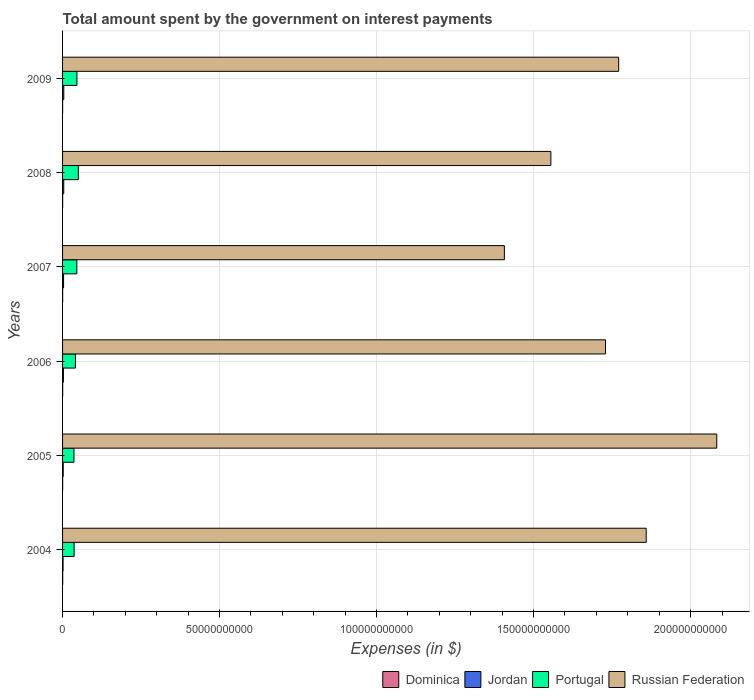How many groups of bars are there?
Offer a very short reply. 6. Are the number of bars per tick equal to the number of legend labels?
Provide a short and direct response. Yes. How many bars are there on the 6th tick from the top?
Provide a short and direct response. 4. How many bars are there on the 1st tick from the bottom?
Your answer should be compact. 4. What is the label of the 2nd group of bars from the top?
Give a very brief answer. 2008. What is the amount spent on interest payments by the government in Russian Federation in 2004?
Ensure brevity in your answer.  1.86e+11. Across all years, what is the maximum amount spent on interest payments by the government in Dominica?
Make the answer very short. 4.16e+07. Across all years, what is the minimum amount spent on interest payments by the government in Dominica?
Make the answer very short. 1.41e+07. In which year was the amount spent on interest payments by the government in Jordan minimum?
Your response must be concise. 2004. What is the total amount spent on interest payments by the government in Portugal in the graph?
Offer a very short reply. 2.55e+1. What is the difference between the amount spent on interest payments by the government in Russian Federation in 2005 and that in 2008?
Ensure brevity in your answer.  5.28e+1. What is the difference between the amount spent on interest payments by the government in Portugal in 2006 and the amount spent on interest payments by the government in Russian Federation in 2007?
Offer a terse response. -1.37e+11. What is the average amount spent on interest payments by the government in Dominica per year?
Your answer should be very brief. 2.82e+07. In the year 2007, what is the difference between the amount spent on interest payments by the government in Jordan and amount spent on interest payments by the government in Portugal?
Your answer should be compact. -4.22e+09. What is the ratio of the amount spent on interest payments by the government in Jordan in 2005 to that in 2007?
Ensure brevity in your answer.  0.65. Is the amount spent on interest payments by the government in Dominica in 2007 less than that in 2009?
Provide a short and direct response. No. What is the difference between the highest and the second highest amount spent on interest payments by the government in Jordan?
Your answer should be very brief. 1.44e+07. What is the difference between the highest and the lowest amount spent on interest payments by the government in Russian Federation?
Give a very brief answer. 6.76e+1. In how many years, is the amount spent on interest payments by the government in Portugal greater than the average amount spent on interest payments by the government in Portugal taken over all years?
Ensure brevity in your answer.  3. What does the 3rd bar from the top in 2008 represents?
Offer a very short reply. Jordan. What does the 3rd bar from the bottom in 2008 represents?
Keep it short and to the point. Portugal. How many bars are there?
Make the answer very short. 24. Are all the bars in the graph horizontal?
Offer a very short reply. Yes. What is the difference between two consecutive major ticks on the X-axis?
Make the answer very short. 5.00e+1. Are the values on the major ticks of X-axis written in scientific E-notation?
Ensure brevity in your answer.  No. Does the graph contain grids?
Your answer should be compact. Yes. How are the legend labels stacked?
Provide a succinct answer. Horizontal. What is the title of the graph?
Ensure brevity in your answer.  Total amount spent by the government on interest payments. Does "Slovak Republic" appear as one of the legend labels in the graph?
Your response must be concise. No. What is the label or title of the X-axis?
Keep it short and to the point. Expenses (in $). What is the Expenses (in $) in Dominica in 2004?
Give a very brief answer. 4.16e+07. What is the Expenses (in $) in Jordan in 2004?
Offer a very short reply. 1.61e+08. What is the Expenses (in $) of Portugal in 2004?
Your response must be concise. 3.68e+09. What is the Expenses (in $) of Russian Federation in 2004?
Offer a terse response. 1.86e+11. What is the Expenses (in $) in Dominica in 2005?
Your answer should be compact. 2.59e+07. What is the Expenses (in $) of Jordan in 2005?
Offer a terse response. 2.07e+08. What is the Expenses (in $) of Portugal in 2005?
Keep it short and to the point. 3.63e+09. What is the Expenses (in $) of Russian Federation in 2005?
Offer a terse response. 2.08e+11. What is the Expenses (in $) of Dominica in 2006?
Offer a terse response. 3.46e+07. What is the Expenses (in $) in Jordan in 2006?
Make the answer very short. 2.66e+08. What is the Expenses (in $) of Portugal in 2006?
Your answer should be very brief. 4.10e+09. What is the Expenses (in $) in Russian Federation in 2006?
Offer a very short reply. 1.73e+11. What is the Expenses (in $) of Dominica in 2007?
Give a very brief answer. 2.82e+07. What is the Expenses (in $) in Jordan in 2007?
Offer a very short reply. 3.21e+08. What is the Expenses (in $) of Portugal in 2007?
Provide a succinct answer. 4.54e+09. What is the Expenses (in $) in Russian Federation in 2007?
Your response must be concise. 1.41e+11. What is the Expenses (in $) in Dominica in 2008?
Provide a short and direct response. 2.45e+07. What is the Expenses (in $) in Jordan in 2008?
Make the answer very short. 3.78e+08. What is the Expenses (in $) of Portugal in 2008?
Give a very brief answer. 5.02e+09. What is the Expenses (in $) in Russian Federation in 2008?
Your answer should be very brief. 1.56e+11. What is the Expenses (in $) in Dominica in 2009?
Ensure brevity in your answer.  1.41e+07. What is the Expenses (in $) in Jordan in 2009?
Provide a short and direct response. 3.92e+08. What is the Expenses (in $) in Portugal in 2009?
Ensure brevity in your answer.  4.58e+09. What is the Expenses (in $) of Russian Federation in 2009?
Keep it short and to the point. 1.77e+11. Across all years, what is the maximum Expenses (in $) of Dominica?
Keep it short and to the point. 4.16e+07. Across all years, what is the maximum Expenses (in $) in Jordan?
Your response must be concise. 3.92e+08. Across all years, what is the maximum Expenses (in $) in Portugal?
Your answer should be compact. 5.02e+09. Across all years, what is the maximum Expenses (in $) in Russian Federation?
Give a very brief answer. 2.08e+11. Across all years, what is the minimum Expenses (in $) in Dominica?
Offer a terse response. 1.41e+07. Across all years, what is the minimum Expenses (in $) in Jordan?
Your answer should be compact. 1.61e+08. Across all years, what is the minimum Expenses (in $) of Portugal?
Give a very brief answer. 3.63e+09. Across all years, what is the minimum Expenses (in $) in Russian Federation?
Provide a short and direct response. 1.41e+11. What is the total Expenses (in $) of Dominica in the graph?
Ensure brevity in your answer.  1.69e+08. What is the total Expenses (in $) of Jordan in the graph?
Your response must be concise. 1.73e+09. What is the total Expenses (in $) of Portugal in the graph?
Give a very brief answer. 2.55e+1. What is the total Expenses (in $) in Russian Federation in the graph?
Your answer should be compact. 1.04e+12. What is the difference between the Expenses (in $) of Dominica in 2004 and that in 2005?
Ensure brevity in your answer.  1.57e+07. What is the difference between the Expenses (in $) of Jordan in 2004 and that in 2005?
Ensure brevity in your answer.  -4.60e+07. What is the difference between the Expenses (in $) in Portugal in 2004 and that in 2005?
Provide a short and direct response. 4.77e+07. What is the difference between the Expenses (in $) of Russian Federation in 2004 and that in 2005?
Offer a terse response. -2.25e+1. What is the difference between the Expenses (in $) in Dominica in 2004 and that in 2006?
Your answer should be compact. 7.00e+06. What is the difference between the Expenses (in $) of Jordan in 2004 and that in 2006?
Give a very brief answer. -1.05e+08. What is the difference between the Expenses (in $) in Portugal in 2004 and that in 2006?
Make the answer very short. -4.15e+08. What is the difference between the Expenses (in $) in Russian Federation in 2004 and that in 2006?
Offer a very short reply. 1.30e+1. What is the difference between the Expenses (in $) of Dominica in 2004 and that in 2007?
Offer a very short reply. 1.34e+07. What is the difference between the Expenses (in $) of Jordan in 2004 and that in 2007?
Your answer should be very brief. -1.60e+08. What is the difference between the Expenses (in $) of Portugal in 2004 and that in 2007?
Ensure brevity in your answer.  -8.60e+08. What is the difference between the Expenses (in $) of Russian Federation in 2004 and that in 2007?
Offer a terse response. 4.52e+1. What is the difference between the Expenses (in $) in Dominica in 2004 and that in 2008?
Make the answer very short. 1.71e+07. What is the difference between the Expenses (in $) of Jordan in 2004 and that in 2008?
Provide a succinct answer. -2.17e+08. What is the difference between the Expenses (in $) of Portugal in 2004 and that in 2008?
Offer a terse response. -1.34e+09. What is the difference between the Expenses (in $) in Russian Federation in 2004 and that in 2008?
Offer a very short reply. 3.04e+1. What is the difference between the Expenses (in $) in Dominica in 2004 and that in 2009?
Provide a succinct answer. 2.75e+07. What is the difference between the Expenses (in $) of Jordan in 2004 and that in 2009?
Keep it short and to the point. -2.31e+08. What is the difference between the Expenses (in $) of Portugal in 2004 and that in 2009?
Provide a succinct answer. -8.97e+08. What is the difference between the Expenses (in $) in Russian Federation in 2004 and that in 2009?
Your answer should be very brief. 8.76e+09. What is the difference between the Expenses (in $) in Dominica in 2005 and that in 2006?
Offer a very short reply. -8.70e+06. What is the difference between the Expenses (in $) of Jordan in 2005 and that in 2006?
Offer a terse response. -5.89e+07. What is the difference between the Expenses (in $) in Portugal in 2005 and that in 2006?
Ensure brevity in your answer.  -4.63e+08. What is the difference between the Expenses (in $) in Russian Federation in 2005 and that in 2006?
Make the answer very short. 3.54e+1. What is the difference between the Expenses (in $) in Dominica in 2005 and that in 2007?
Provide a succinct answer. -2.30e+06. What is the difference between the Expenses (in $) in Jordan in 2005 and that in 2007?
Provide a short and direct response. -1.14e+08. What is the difference between the Expenses (in $) in Portugal in 2005 and that in 2007?
Make the answer very short. -9.07e+08. What is the difference between the Expenses (in $) of Russian Federation in 2005 and that in 2007?
Keep it short and to the point. 6.76e+1. What is the difference between the Expenses (in $) of Dominica in 2005 and that in 2008?
Ensure brevity in your answer.  1.40e+06. What is the difference between the Expenses (in $) in Jordan in 2005 and that in 2008?
Offer a very short reply. -1.71e+08. What is the difference between the Expenses (in $) of Portugal in 2005 and that in 2008?
Provide a succinct answer. -1.39e+09. What is the difference between the Expenses (in $) of Russian Federation in 2005 and that in 2008?
Your answer should be very brief. 5.28e+1. What is the difference between the Expenses (in $) of Dominica in 2005 and that in 2009?
Make the answer very short. 1.18e+07. What is the difference between the Expenses (in $) in Jordan in 2005 and that in 2009?
Give a very brief answer. -1.85e+08. What is the difference between the Expenses (in $) of Portugal in 2005 and that in 2009?
Keep it short and to the point. -9.44e+08. What is the difference between the Expenses (in $) in Russian Federation in 2005 and that in 2009?
Make the answer very short. 3.12e+1. What is the difference between the Expenses (in $) of Dominica in 2006 and that in 2007?
Your answer should be compact. 6.40e+06. What is the difference between the Expenses (in $) in Jordan in 2006 and that in 2007?
Your response must be concise. -5.49e+07. What is the difference between the Expenses (in $) in Portugal in 2006 and that in 2007?
Ensure brevity in your answer.  -4.44e+08. What is the difference between the Expenses (in $) in Russian Federation in 2006 and that in 2007?
Your response must be concise. 3.22e+1. What is the difference between the Expenses (in $) of Dominica in 2006 and that in 2008?
Offer a terse response. 1.01e+07. What is the difference between the Expenses (in $) in Jordan in 2006 and that in 2008?
Your response must be concise. -1.12e+08. What is the difference between the Expenses (in $) in Portugal in 2006 and that in 2008?
Make the answer very short. -9.23e+08. What is the difference between the Expenses (in $) of Russian Federation in 2006 and that in 2008?
Make the answer very short. 1.74e+1. What is the difference between the Expenses (in $) in Dominica in 2006 and that in 2009?
Ensure brevity in your answer.  2.05e+07. What is the difference between the Expenses (in $) of Jordan in 2006 and that in 2009?
Ensure brevity in your answer.  -1.26e+08. What is the difference between the Expenses (in $) of Portugal in 2006 and that in 2009?
Your response must be concise. -4.81e+08. What is the difference between the Expenses (in $) of Russian Federation in 2006 and that in 2009?
Offer a very short reply. -4.20e+09. What is the difference between the Expenses (in $) of Dominica in 2007 and that in 2008?
Offer a terse response. 3.70e+06. What is the difference between the Expenses (in $) in Jordan in 2007 and that in 2008?
Offer a terse response. -5.69e+07. What is the difference between the Expenses (in $) in Portugal in 2007 and that in 2008?
Offer a terse response. -4.79e+08. What is the difference between the Expenses (in $) of Russian Federation in 2007 and that in 2008?
Your answer should be compact. -1.48e+1. What is the difference between the Expenses (in $) of Dominica in 2007 and that in 2009?
Provide a short and direct response. 1.41e+07. What is the difference between the Expenses (in $) of Jordan in 2007 and that in 2009?
Your response must be concise. -7.13e+07. What is the difference between the Expenses (in $) of Portugal in 2007 and that in 2009?
Your answer should be very brief. -3.71e+07. What is the difference between the Expenses (in $) of Russian Federation in 2007 and that in 2009?
Ensure brevity in your answer.  -3.64e+1. What is the difference between the Expenses (in $) of Dominica in 2008 and that in 2009?
Your response must be concise. 1.04e+07. What is the difference between the Expenses (in $) in Jordan in 2008 and that in 2009?
Your response must be concise. -1.44e+07. What is the difference between the Expenses (in $) in Portugal in 2008 and that in 2009?
Offer a terse response. 4.42e+08. What is the difference between the Expenses (in $) of Russian Federation in 2008 and that in 2009?
Your answer should be very brief. -2.16e+1. What is the difference between the Expenses (in $) of Dominica in 2004 and the Expenses (in $) of Jordan in 2005?
Give a very brief answer. -1.66e+08. What is the difference between the Expenses (in $) in Dominica in 2004 and the Expenses (in $) in Portugal in 2005?
Your response must be concise. -3.59e+09. What is the difference between the Expenses (in $) of Dominica in 2004 and the Expenses (in $) of Russian Federation in 2005?
Keep it short and to the point. -2.08e+11. What is the difference between the Expenses (in $) in Jordan in 2004 and the Expenses (in $) in Portugal in 2005?
Ensure brevity in your answer.  -3.47e+09. What is the difference between the Expenses (in $) in Jordan in 2004 and the Expenses (in $) in Russian Federation in 2005?
Your answer should be compact. -2.08e+11. What is the difference between the Expenses (in $) in Portugal in 2004 and the Expenses (in $) in Russian Federation in 2005?
Give a very brief answer. -2.05e+11. What is the difference between the Expenses (in $) of Dominica in 2004 and the Expenses (in $) of Jordan in 2006?
Make the answer very short. -2.24e+08. What is the difference between the Expenses (in $) in Dominica in 2004 and the Expenses (in $) in Portugal in 2006?
Your answer should be very brief. -4.05e+09. What is the difference between the Expenses (in $) of Dominica in 2004 and the Expenses (in $) of Russian Federation in 2006?
Provide a short and direct response. -1.73e+11. What is the difference between the Expenses (in $) of Jordan in 2004 and the Expenses (in $) of Portugal in 2006?
Make the answer very short. -3.93e+09. What is the difference between the Expenses (in $) in Jordan in 2004 and the Expenses (in $) in Russian Federation in 2006?
Provide a succinct answer. -1.73e+11. What is the difference between the Expenses (in $) of Portugal in 2004 and the Expenses (in $) of Russian Federation in 2006?
Your answer should be very brief. -1.69e+11. What is the difference between the Expenses (in $) in Dominica in 2004 and the Expenses (in $) in Jordan in 2007?
Your response must be concise. -2.79e+08. What is the difference between the Expenses (in $) in Dominica in 2004 and the Expenses (in $) in Portugal in 2007?
Give a very brief answer. -4.50e+09. What is the difference between the Expenses (in $) of Dominica in 2004 and the Expenses (in $) of Russian Federation in 2007?
Make the answer very short. -1.41e+11. What is the difference between the Expenses (in $) of Jordan in 2004 and the Expenses (in $) of Portugal in 2007?
Provide a succinct answer. -4.38e+09. What is the difference between the Expenses (in $) of Jordan in 2004 and the Expenses (in $) of Russian Federation in 2007?
Your response must be concise. -1.41e+11. What is the difference between the Expenses (in $) of Portugal in 2004 and the Expenses (in $) of Russian Federation in 2007?
Ensure brevity in your answer.  -1.37e+11. What is the difference between the Expenses (in $) of Dominica in 2004 and the Expenses (in $) of Jordan in 2008?
Give a very brief answer. -3.36e+08. What is the difference between the Expenses (in $) of Dominica in 2004 and the Expenses (in $) of Portugal in 2008?
Your response must be concise. -4.98e+09. What is the difference between the Expenses (in $) in Dominica in 2004 and the Expenses (in $) in Russian Federation in 2008?
Your answer should be compact. -1.55e+11. What is the difference between the Expenses (in $) in Jordan in 2004 and the Expenses (in $) in Portugal in 2008?
Offer a very short reply. -4.86e+09. What is the difference between the Expenses (in $) of Jordan in 2004 and the Expenses (in $) of Russian Federation in 2008?
Give a very brief answer. -1.55e+11. What is the difference between the Expenses (in $) in Portugal in 2004 and the Expenses (in $) in Russian Federation in 2008?
Ensure brevity in your answer.  -1.52e+11. What is the difference between the Expenses (in $) of Dominica in 2004 and the Expenses (in $) of Jordan in 2009?
Provide a succinct answer. -3.51e+08. What is the difference between the Expenses (in $) of Dominica in 2004 and the Expenses (in $) of Portugal in 2009?
Provide a short and direct response. -4.54e+09. What is the difference between the Expenses (in $) in Dominica in 2004 and the Expenses (in $) in Russian Federation in 2009?
Provide a short and direct response. -1.77e+11. What is the difference between the Expenses (in $) of Jordan in 2004 and the Expenses (in $) of Portugal in 2009?
Ensure brevity in your answer.  -4.42e+09. What is the difference between the Expenses (in $) of Jordan in 2004 and the Expenses (in $) of Russian Federation in 2009?
Provide a succinct answer. -1.77e+11. What is the difference between the Expenses (in $) in Portugal in 2004 and the Expenses (in $) in Russian Federation in 2009?
Ensure brevity in your answer.  -1.73e+11. What is the difference between the Expenses (in $) of Dominica in 2005 and the Expenses (in $) of Jordan in 2006?
Your answer should be compact. -2.40e+08. What is the difference between the Expenses (in $) of Dominica in 2005 and the Expenses (in $) of Portugal in 2006?
Your answer should be compact. -4.07e+09. What is the difference between the Expenses (in $) of Dominica in 2005 and the Expenses (in $) of Russian Federation in 2006?
Your response must be concise. -1.73e+11. What is the difference between the Expenses (in $) in Jordan in 2005 and the Expenses (in $) in Portugal in 2006?
Offer a very short reply. -3.89e+09. What is the difference between the Expenses (in $) in Jordan in 2005 and the Expenses (in $) in Russian Federation in 2006?
Your answer should be compact. -1.73e+11. What is the difference between the Expenses (in $) of Portugal in 2005 and the Expenses (in $) of Russian Federation in 2006?
Offer a terse response. -1.69e+11. What is the difference between the Expenses (in $) in Dominica in 2005 and the Expenses (in $) in Jordan in 2007?
Your answer should be compact. -2.95e+08. What is the difference between the Expenses (in $) of Dominica in 2005 and the Expenses (in $) of Portugal in 2007?
Make the answer very short. -4.51e+09. What is the difference between the Expenses (in $) in Dominica in 2005 and the Expenses (in $) in Russian Federation in 2007?
Offer a terse response. -1.41e+11. What is the difference between the Expenses (in $) of Jordan in 2005 and the Expenses (in $) of Portugal in 2007?
Give a very brief answer. -4.33e+09. What is the difference between the Expenses (in $) of Jordan in 2005 and the Expenses (in $) of Russian Federation in 2007?
Your response must be concise. -1.40e+11. What is the difference between the Expenses (in $) of Portugal in 2005 and the Expenses (in $) of Russian Federation in 2007?
Offer a very short reply. -1.37e+11. What is the difference between the Expenses (in $) in Dominica in 2005 and the Expenses (in $) in Jordan in 2008?
Give a very brief answer. -3.52e+08. What is the difference between the Expenses (in $) of Dominica in 2005 and the Expenses (in $) of Portugal in 2008?
Offer a very short reply. -4.99e+09. What is the difference between the Expenses (in $) in Dominica in 2005 and the Expenses (in $) in Russian Federation in 2008?
Provide a short and direct response. -1.55e+11. What is the difference between the Expenses (in $) of Jordan in 2005 and the Expenses (in $) of Portugal in 2008?
Your answer should be compact. -4.81e+09. What is the difference between the Expenses (in $) of Jordan in 2005 and the Expenses (in $) of Russian Federation in 2008?
Your response must be concise. -1.55e+11. What is the difference between the Expenses (in $) in Portugal in 2005 and the Expenses (in $) in Russian Federation in 2008?
Your response must be concise. -1.52e+11. What is the difference between the Expenses (in $) in Dominica in 2005 and the Expenses (in $) in Jordan in 2009?
Give a very brief answer. -3.66e+08. What is the difference between the Expenses (in $) in Dominica in 2005 and the Expenses (in $) in Portugal in 2009?
Provide a short and direct response. -4.55e+09. What is the difference between the Expenses (in $) of Dominica in 2005 and the Expenses (in $) of Russian Federation in 2009?
Provide a short and direct response. -1.77e+11. What is the difference between the Expenses (in $) in Jordan in 2005 and the Expenses (in $) in Portugal in 2009?
Offer a terse response. -4.37e+09. What is the difference between the Expenses (in $) of Jordan in 2005 and the Expenses (in $) of Russian Federation in 2009?
Give a very brief answer. -1.77e+11. What is the difference between the Expenses (in $) of Portugal in 2005 and the Expenses (in $) of Russian Federation in 2009?
Ensure brevity in your answer.  -1.73e+11. What is the difference between the Expenses (in $) in Dominica in 2006 and the Expenses (in $) in Jordan in 2007?
Your answer should be compact. -2.86e+08. What is the difference between the Expenses (in $) in Dominica in 2006 and the Expenses (in $) in Portugal in 2007?
Offer a very short reply. -4.51e+09. What is the difference between the Expenses (in $) of Dominica in 2006 and the Expenses (in $) of Russian Federation in 2007?
Offer a very short reply. -1.41e+11. What is the difference between the Expenses (in $) of Jordan in 2006 and the Expenses (in $) of Portugal in 2007?
Give a very brief answer. -4.27e+09. What is the difference between the Expenses (in $) of Jordan in 2006 and the Expenses (in $) of Russian Federation in 2007?
Make the answer very short. -1.40e+11. What is the difference between the Expenses (in $) of Portugal in 2006 and the Expenses (in $) of Russian Federation in 2007?
Your response must be concise. -1.37e+11. What is the difference between the Expenses (in $) of Dominica in 2006 and the Expenses (in $) of Jordan in 2008?
Ensure brevity in your answer.  -3.43e+08. What is the difference between the Expenses (in $) of Dominica in 2006 and the Expenses (in $) of Portugal in 2008?
Provide a short and direct response. -4.98e+09. What is the difference between the Expenses (in $) of Dominica in 2006 and the Expenses (in $) of Russian Federation in 2008?
Provide a succinct answer. -1.55e+11. What is the difference between the Expenses (in $) of Jordan in 2006 and the Expenses (in $) of Portugal in 2008?
Your answer should be very brief. -4.75e+09. What is the difference between the Expenses (in $) of Jordan in 2006 and the Expenses (in $) of Russian Federation in 2008?
Your answer should be compact. -1.55e+11. What is the difference between the Expenses (in $) in Portugal in 2006 and the Expenses (in $) in Russian Federation in 2008?
Your answer should be very brief. -1.51e+11. What is the difference between the Expenses (in $) of Dominica in 2006 and the Expenses (in $) of Jordan in 2009?
Provide a short and direct response. -3.58e+08. What is the difference between the Expenses (in $) in Dominica in 2006 and the Expenses (in $) in Portugal in 2009?
Provide a short and direct response. -4.54e+09. What is the difference between the Expenses (in $) of Dominica in 2006 and the Expenses (in $) of Russian Federation in 2009?
Provide a succinct answer. -1.77e+11. What is the difference between the Expenses (in $) in Jordan in 2006 and the Expenses (in $) in Portugal in 2009?
Your answer should be very brief. -4.31e+09. What is the difference between the Expenses (in $) of Jordan in 2006 and the Expenses (in $) of Russian Federation in 2009?
Your answer should be compact. -1.77e+11. What is the difference between the Expenses (in $) in Portugal in 2006 and the Expenses (in $) in Russian Federation in 2009?
Ensure brevity in your answer.  -1.73e+11. What is the difference between the Expenses (in $) of Dominica in 2007 and the Expenses (in $) of Jordan in 2008?
Offer a terse response. -3.50e+08. What is the difference between the Expenses (in $) of Dominica in 2007 and the Expenses (in $) of Portugal in 2008?
Keep it short and to the point. -4.99e+09. What is the difference between the Expenses (in $) in Dominica in 2007 and the Expenses (in $) in Russian Federation in 2008?
Make the answer very short. -1.55e+11. What is the difference between the Expenses (in $) of Jordan in 2007 and the Expenses (in $) of Portugal in 2008?
Provide a succinct answer. -4.70e+09. What is the difference between the Expenses (in $) of Jordan in 2007 and the Expenses (in $) of Russian Federation in 2008?
Provide a short and direct response. -1.55e+11. What is the difference between the Expenses (in $) in Portugal in 2007 and the Expenses (in $) in Russian Federation in 2008?
Keep it short and to the point. -1.51e+11. What is the difference between the Expenses (in $) in Dominica in 2007 and the Expenses (in $) in Jordan in 2009?
Offer a very short reply. -3.64e+08. What is the difference between the Expenses (in $) of Dominica in 2007 and the Expenses (in $) of Portugal in 2009?
Ensure brevity in your answer.  -4.55e+09. What is the difference between the Expenses (in $) in Dominica in 2007 and the Expenses (in $) in Russian Federation in 2009?
Give a very brief answer. -1.77e+11. What is the difference between the Expenses (in $) in Jordan in 2007 and the Expenses (in $) in Portugal in 2009?
Provide a succinct answer. -4.26e+09. What is the difference between the Expenses (in $) of Jordan in 2007 and the Expenses (in $) of Russian Federation in 2009?
Make the answer very short. -1.77e+11. What is the difference between the Expenses (in $) in Portugal in 2007 and the Expenses (in $) in Russian Federation in 2009?
Your answer should be very brief. -1.73e+11. What is the difference between the Expenses (in $) of Dominica in 2008 and the Expenses (in $) of Jordan in 2009?
Your response must be concise. -3.68e+08. What is the difference between the Expenses (in $) of Dominica in 2008 and the Expenses (in $) of Portugal in 2009?
Your answer should be very brief. -4.55e+09. What is the difference between the Expenses (in $) in Dominica in 2008 and the Expenses (in $) in Russian Federation in 2009?
Provide a succinct answer. -1.77e+11. What is the difference between the Expenses (in $) in Jordan in 2008 and the Expenses (in $) in Portugal in 2009?
Provide a short and direct response. -4.20e+09. What is the difference between the Expenses (in $) in Jordan in 2008 and the Expenses (in $) in Russian Federation in 2009?
Your answer should be compact. -1.77e+11. What is the difference between the Expenses (in $) of Portugal in 2008 and the Expenses (in $) of Russian Federation in 2009?
Give a very brief answer. -1.72e+11. What is the average Expenses (in $) in Dominica per year?
Your answer should be compact. 2.82e+07. What is the average Expenses (in $) in Jordan per year?
Offer a terse response. 2.88e+08. What is the average Expenses (in $) of Portugal per year?
Make the answer very short. 4.26e+09. What is the average Expenses (in $) of Russian Federation per year?
Provide a succinct answer. 1.73e+11. In the year 2004, what is the difference between the Expenses (in $) in Dominica and Expenses (in $) in Jordan?
Ensure brevity in your answer.  -1.20e+08. In the year 2004, what is the difference between the Expenses (in $) of Dominica and Expenses (in $) of Portugal?
Your response must be concise. -3.64e+09. In the year 2004, what is the difference between the Expenses (in $) in Dominica and Expenses (in $) in Russian Federation?
Provide a short and direct response. -1.86e+11. In the year 2004, what is the difference between the Expenses (in $) of Jordan and Expenses (in $) of Portugal?
Your response must be concise. -3.52e+09. In the year 2004, what is the difference between the Expenses (in $) of Jordan and Expenses (in $) of Russian Federation?
Make the answer very short. -1.86e+11. In the year 2004, what is the difference between the Expenses (in $) in Portugal and Expenses (in $) in Russian Federation?
Make the answer very short. -1.82e+11. In the year 2005, what is the difference between the Expenses (in $) of Dominica and Expenses (in $) of Jordan?
Keep it short and to the point. -1.81e+08. In the year 2005, what is the difference between the Expenses (in $) in Dominica and Expenses (in $) in Portugal?
Offer a very short reply. -3.61e+09. In the year 2005, what is the difference between the Expenses (in $) in Dominica and Expenses (in $) in Russian Federation?
Provide a succinct answer. -2.08e+11. In the year 2005, what is the difference between the Expenses (in $) of Jordan and Expenses (in $) of Portugal?
Offer a terse response. -3.43e+09. In the year 2005, what is the difference between the Expenses (in $) of Jordan and Expenses (in $) of Russian Federation?
Your answer should be very brief. -2.08e+11. In the year 2005, what is the difference between the Expenses (in $) of Portugal and Expenses (in $) of Russian Federation?
Give a very brief answer. -2.05e+11. In the year 2006, what is the difference between the Expenses (in $) of Dominica and Expenses (in $) of Jordan?
Provide a succinct answer. -2.31e+08. In the year 2006, what is the difference between the Expenses (in $) of Dominica and Expenses (in $) of Portugal?
Ensure brevity in your answer.  -4.06e+09. In the year 2006, what is the difference between the Expenses (in $) of Dominica and Expenses (in $) of Russian Federation?
Your response must be concise. -1.73e+11. In the year 2006, what is the difference between the Expenses (in $) of Jordan and Expenses (in $) of Portugal?
Ensure brevity in your answer.  -3.83e+09. In the year 2006, what is the difference between the Expenses (in $) of Jordan and Expenses (in $) of Russian Federation?
Ensure brevity in your answer.  -1.73e+11. In the year 2006, what is the difference between the Expenses (in $) of Portugal and Expenses (in $) of Russian Federation?
Ensure brevity in your answer.  -1.69e+11. In the year 2007, what is the difference between the Expenses (in $) in Dominica and Expenses (in $) in Jordan?
Make the answer very short. -2.93e+08. In the year 2007, what is the difference between the Expenses (in $) in Dominica and Expenses (in $) in Portugal?
Your answer should be very brief. -4.51e+09. In the year 2007, what is the difference between the Expenses (in $) of Dominica and Expenses (in $) of Russian Federation?
Your answer should be very brief. -1.41e+11. In the year 2007, what is the difference between the Expenses (in $) in Jordan and Expenses (in $) in Portugal?
Offer a very short reply. -4.22e+09. In the year 2007, what is the difference between the Expenses (in $) in Jordan and Expenses (in $) in Russian Federation?
Give a very brief answer. -1.40e+11. In the year 2007, what is the difference between the Expenses (in $) in Portugal and Expenses (in $) in Russian Federation?
Offer a terse response. -1.36e+11. In the year 2008, what is the difference between the Expenses (in $) in Dominica and Expenses (in $) in Jordan?
Give a very brief answer. -3.53e+08. In the year 2008, what is the difference between the Expenses (in $) of Dominica and Expenses (in $) of Portugal?
Give a very brief answer. -4.99e+09. In the year 2008, what is the difference between the Expenses (in $) in Dominica and Expenses (in $) in Russian Federation?
Offer a terse response. -1.55e+11. In the year 2008, what is the difference between the Expenses (in $) in Jordan and Expenses (in $) in Portugal?
Make the answer very short. -4.64e+09. In the year 2008, what is the difference between the Expenses (in $) in Jordan and Expenses (in $) in Russian Federation?
Ensure brevity in your answer.  -1.55e+11. In the year 2008, what is the difference between the Expenses (in $) in Portugal and Expenses (in $) in Russian Federation?
Keep it short and to the point. -1.50e+11. In the year 2009, what is the difference between the Expenses (in $) in Dominica and Expenses (in $) in Jordan?
Your response must be concise. -3.78e+08. In the year 2009, what is the difference between the Expenses (in $) of Dominica and Expenses (in $) of Portugal?
Make the answer very short. -4.56e+09. In the year 2009, what is the difference between the Expenses (in $) in Dominica and Expenses (in $) in Russian Federation?
Provide a succinct answer. -1.77e+11. In the year 2009, what is the difference between the Expenses (in $) in Jordan and Expenses (in $) in Portugal?
Offer a very short reply. -4.19e+09. In the year 2009, what is the difference between the Expenses (in $) in Jordan and Expenses (in $) in Russian Federation?
Your answer should be compact. -1.77e+11. In the year 2009, what is the difference between the Expenses (in $) of Portugal and Expenses (in $) of Russian Federation?
Give a very brief answer. -1.73e+11. What is the ratio of the Expenses (in $) of Dominica in 2004 to that in 2005?
Your response must be concise. 1.61. What is the ratio of the Expenses (in $) of Jordan in 2004 to that in 2005?
Offer a terse response. 0.78. What is the ratio of the Expenses (in $) of Portugal in 2004 to that in 2005?
Provide a short and direct response. 1.01. What is the ratio of the Expenses (in $) of Russian Federation in 2004 to that in 2005?
Your answer should be compact. 0.89. What is the ratio of the Expenses (in $) of Dominica in 2004 to that in 2006?
Offer a very short reply. 1.2. What is the ratio of the Expenses (in $) in Jordan in 2004 to that in 2006?
Offer a terse response. 0.61. What is the ratio of the Expenses (in $) in Portugal in 2004 to that in 2006?
Keep it short and to the point. 0.9. What is the ratio of the Expenses (in $) in Russian Federation in 2004 to that in 2006?
Ensure brevity in your answer.  1.07. What is the ratio of the Expenses (in $) in Dominica in 2004 to that in 2007?
Your answer should be very brief. 1.48. What is the ratio of the Expenses (in $) of Jordan in 2004 to that in 2007?
Offer a terse response. 0.5. What is the ratio of the Expenses (in $) in Portugal in 2004 to that in 2007?
Give a very brief answer. 0.81. What is the ratio of the Expenses (in $) in Russian Federation in 2004 to that in 2007?
Provide a succinct answer. 1.32. What is the ratio of the Expenses (in $) in Dominica in 2004 to that in 2008?
Offer a terse response. 1.7. What is the ratio of the Expenses (in $) of Jordan in 2004 to that in 2008?
Ensure brevity in your answer.  0.43. What is the ratio of the Expenses (in $) of Portugal in 2004 to that in 2008?
Offer a terse response. 0.73. What is the ratio of the Expenses (in $) in Russian Federation in 2004 to that in 2008?
Provide a succinct answer. 1.2. What is the ratio of the Expenses (in $) in Dominica in 2004 to that in 2009?
Keep it short and to the point. 2.95. What is the ratio of the Expenses (in $) of Jordan in 2004 to that in 2009?
Make the answer very short. 0.41. What is the ratio of the Expenses (in $) in Portugal in 2004 to that in 2009?
Provide a succinct answer. 0.8. What is the ratio of the Expenses (in $) in Russian Federation in 2004 to that in 2009?
Keep it short and to the point. 1.05. What is the ratio of the Expenses (in $) of Dominica in 2005 to that in 2006?
Make the answer very short. 0.75. What is the ratio of the Expenses (in $) of Jordan in 2005 to that in 2006?
Your answer should be compact. 0.78. What is the ratio of the Expenses (in $) of Portugal in 2005 to that in 2006?
Provide a succinct answer. 0.89. What is the ratio of the Expenses (in $) of Russian Federation in 2005 to that in 2006?
Provide a short and direct response. 1.21. What is the ratio of the Expenses (in $) in Dominica in 2005 to that in 2007?
Offer a very short reply. 0.92. What is the ratio of the Expenses (in $) in Jordan in 2005 to that in 2007?
Ensure brevity in your answer.  0.65. What is the ratio of the Expenses (in $) of Portugal in 2005 to that in 2007?
Ensure brevity in your answer.  0.8. What is the ratio of the Expenses (in $) in Russian Federation in 2005 to that in 2007?
Your answer should be very brief. 1.48. What is the ratio of the Expenses (in $) of Dominica in 2005 to that in 2008?
Your answer should be very brief. 1.06. What is the ratio of the Expenses (in $) of Jordan in 2005 to that in 2008?
Give a very brief answer. 0.55. What is the ratio of the Expenses (in $) of Portugal in 2005 to that in 2008?
Keep it short and to the point. 0.72. What is the ratio of the Expenses (in $) in Russian Federation in 2005 to that in 2008?
Provide a succinct answer. 1.34. What is the ratio of the Expenses (in $) of Dominica in 2005 to that in 2009?
Your answer should be very brief. 1.84. What is the ratio of the Expenses (in $) of Jordan in 2005 to that in 2009?
Offer a very short reply. 0.53. What is the ratio of the Expenses (in $) of Portugal in 2005 to that in 2009?
Provide a succinct answer. 0.79. What is the ratio of the Expenses (in $) of Russian Federation in 2005 to that in 2009?
Offer a very short reply. 1.18. What is the ratio of the Expenses (in $) in Dominica in 2006 to that in 2007?
Keep it short and to the point. 1.23. What is the ratio of the Expenses (in $) in Jordan in 2006 to that in 2007?
Your answer should be compact. 0.83. What is the ratio of the Expenses (in $) in Portugal in 2006 to that in 2007?
Provide a succinct answer. 0.9. What is the ratio of the Expenses (in $) of Russian Federation in 2006 to that in 2007?
Ensure brevity in your answer.  1.23. What is the ratio of the Expenses (in $) of Dominica in 2006 to that in 2008?
Ensure brevity in your answer.  1.41. What is the ratio of the Expenses (in $) in Jordan in 2006 to that in 2008?
Keep it short and to the point. 0.7. What is the ratio of the Expenses (in $) in Portugal in 2006 to that in 2008?
Make the answer very short. 0.82. What is the ratio of the Expenses (in $) of Russian Federation in 2006 to that in 2008?
Offer a terse response. 1.11. What is the ratio of the Expenses (in $) in Dominica in 2006 to that in 2009?
Keep it short and to the point. 2.45. What is the ratio of the Expenses (in $) in Jordan in 2006 to that in 2009?
Offer a terse response. 0.68. What is the ratio of the Expenses (in $) in Portugal in 2006 to that in 2009?
Offer a terse response. 0.89. What is the ratio of the Expenses (in $) of Russian Federation in 2006 to that in 2009?
Give a very brief answer. 0.98. What is the ratio of the Expenses (in $) of Dominica in 2007 to that in 2008?
Provide a succinct answer. 1.15. What is the ratio of the Expenses (in $) of Jordan in 2007 to that in 2008?
Your answer should be compact. 0.85. What is the ratio of the Expenses (in $) in Portugal in 2007 to that in 2008?
Your answer should be compact. 0.9. What is the ratio of the Expenses (in $) in Russian Federation in 2007 to that in 2008?
Offer a very short reply. 0.9. What is the ratio of the Expenses (in $) in Dominica in 2007 to that in 2009?
Your response must be concise. 2. What is the ratio of the Expenses (in $) of Jordan in 2007 to that in 2009?
Offer a very short reply. 0.82. What is the ratio of the Expenses (in $) of Portugal in 2007 to that in 2009?
Ensure brevity in your answer.  0.99. What is the ratio of the Expenses (in $) of Russian Federation in 2007 to that in 2009?
Keep it short and to the point. 0.79. What is the ratio of the Expenses (in $) in Dominica in 2008 to that in 2009?
Provide a short and direct response. 1.74. What is the ratio of the Expenses (in $) of Jordan in 2008 to that in 2009?
Make the answer very short. 0.96. What is the ratio of the Expenses (in $) of Portugal in 2008 to that in 2009?
Make the answer very short. 1.1. What is the ratio of the Expenses (in $) in Russian Federation in 2008 to that in 2009?
Give a very brief answer. 0.88. What is the difference between the highest and the second highest Expenses (in $) of Dominica?
Provide a short and direct response. 7.00e+06. What is the difference between the highest and the second highest Expenses (in $) in Jordan?
Make the answer very short. 1.44e+07. What is the difference between the highest and the second highest Expenses (in $) of Portugal?
Your response must be concise. 4.42e+08. What is the difference between the highest and the second highest Expenses (in $) of Russian Federation?
Make the answer very short. 2.25e+1. What is the difference between the highest and the lowest Expenses (in $) of Dominica?
Keep it short and to the point. 2.75e+07. What is the difference between the highest and the lowest Expenses (in $) of Jordan?
Your answer should be very brief. 2.31e+08. What is the difference between the highest and the lowest Expenses (in $) in Portugal?
Offer a very short reply. 1.39e+09. What is the difference between the highest and the lowest Expenses (in $) of Russian Federation?
Make the answer very short. 6.76e+1. 